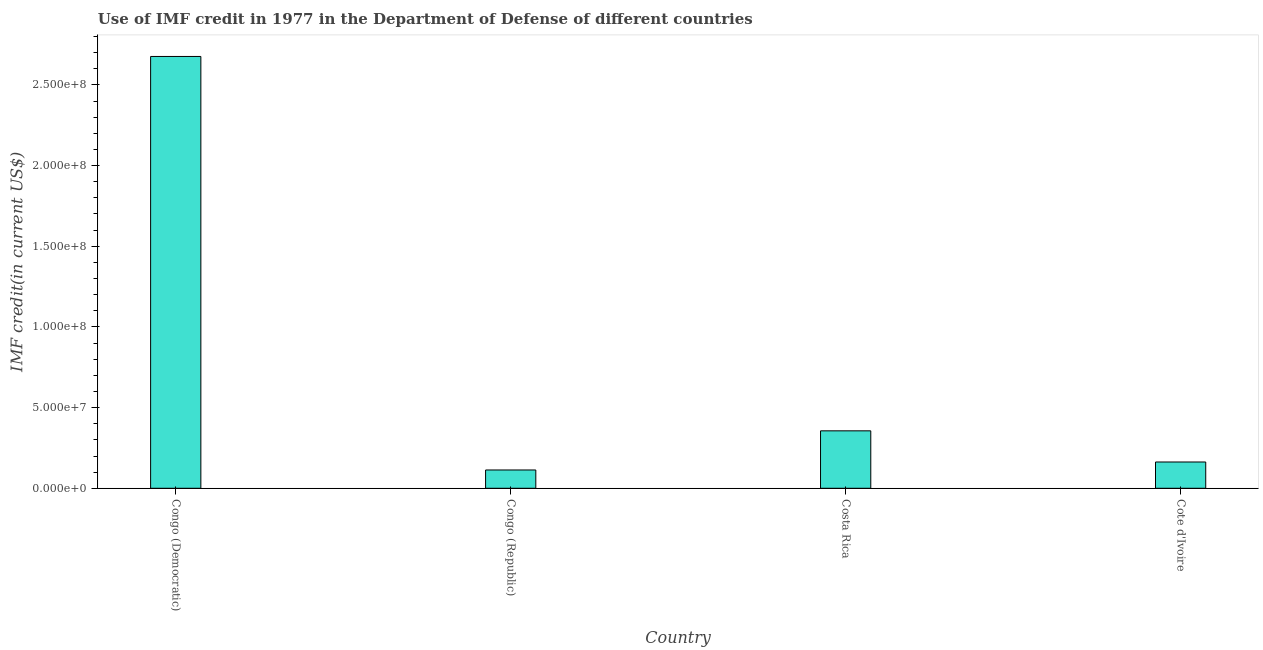Does the graph contain grids?
Provide a short and direct response. No. What is the title of the graph?
Give a very brief answer. Use of IMF credit in 1977 in the Department of Defense of different countries. What is the label or title of the X-axis?
Provide a short and direct response. Country. What is the label or title of the Y-axis?
Your response must be concise. IMF credit(in current US$). What is the use of imf credit in dod in Costa Rica?
Your response must be concise. 3.56e+07. Across all countries, what is the maximum use of imf credit in dod?
Your answer should be very brief. 2.68e+08. Across all countries, what is the minimum use of imf credit in dod?
Offer a very short reply. 1.13e+07. In which country was the use of imf credit in dod maximum?
Your response must be concise. Congo (Democratic). In which country was the use of imf credit in dod minimum?
Your answer should be compact. Congo (Republic). What is the sum of the use of imf credit in dod?
Provide a succinct answer. 3.31e+08. What is the difference between the use of imf credit in dod in Congo (Republic) and Costa Rica?
Make the answer very short. -2.43e+07. What is the average use of imf credit in dod per country?
Offer a very short reply. 8.27e+07. What is the median use of imf credit in dod?
Provide a short and direct response. 2.59e+07. In how many countries, is the use of imf credit in dod greater than 230000000 US$?
Give a very brief answer. 1. What is the ratio of the use of imf credit in dod in Congo (Democratic) to that in Costa Rica?
Provide a short and direct response. 7.52. Is the use of imf credit in dod in Congo (Republic) less than that in Cote d'Ivoire?
Make the answer very short. Yes. Is the difference between the use of imf credit in dod in Congo (Republic) and Costa Rica greater than the difference between any two countries?
Offer a very short reply. No. What is the difference between the highest and the second highest use of imf credit in dod?
Offer a terse response. 2.32e+08. What is the difference between the highest and the lowest use of imf credit in dod?
Make the answer very short. 2.56e+08. What is the IMF credit(in current US$) in Congo (Democratic)?
Make the answer very short. 2.68e+08. What is the IMF credit(in current US$) in Congo (Republic)?
Offer a terse response. 1.13e+07. What is the IMF credit(in current US$) of Costa Rica?
Your response must be concise. 3.56e+07. What is the IMF credit(in current US$) in Cote d'Ivoire?
Provide a succinct answer. 1.63e+07. What is the difference between the IMF credit(in current US$) in Congo (Democratic) and Congo (Republic)?
Your answer should be very brief. 2.56e+08. What is the difference between the IMF credit(in current US$) in Congo (Democratic) and Costa Rica?
Make the answer very short. 2.32e+08. What is the difference between the IMF credit(in current US$) in Congo (Democratic) and Cote d'Ivoire?
Offer a very short reply. 2.51e+08. What is the difference between the IMF credit(in current US$) in Congo (Republic) and Costa Rica?
Your answer should be compact. -2.43e+07. What is the difference between the IMF credit(in current US$) in Congo (Republic) and Cote d'Ivoire?
Your answer should be very brief. -4.94e+06. What is the difference between the IMF credit(in current US$) in Costa Rica and Cote d'Ivoire?
Your response must be concise. 1.93e+07. What is the ratio of the IMF credit(in current US$) in Congo (Democratic) to that in Congo (Republic)?
Keep it short and to the point. 23.59. What is the ratio of the IMF credit(in current US$) in Congo (Democratic) to that in Costa Rica?
Provide a short and direct response. 7.52. What is the ratio of the IMF credit(in current US$) in Congo (Democratic) to that in Cote d'Ivoire?
Your answer should be compact. 16.43. What is the ratio of the IMF credit(in current US$) in Congo (Republic) to that in Costa Rica?
Provide a succinct answer. 0.32. What is the ratio of the IMF credit(in current US$) in Congo (Republic) to that in Cote d'Ivoire?
Provide a short and direct response. 0.7. What is the ratio of the IMF credit(in current US$) in Costa Rica to that in Cote d'Ivoire?
Make the answer very short. 2.19. 